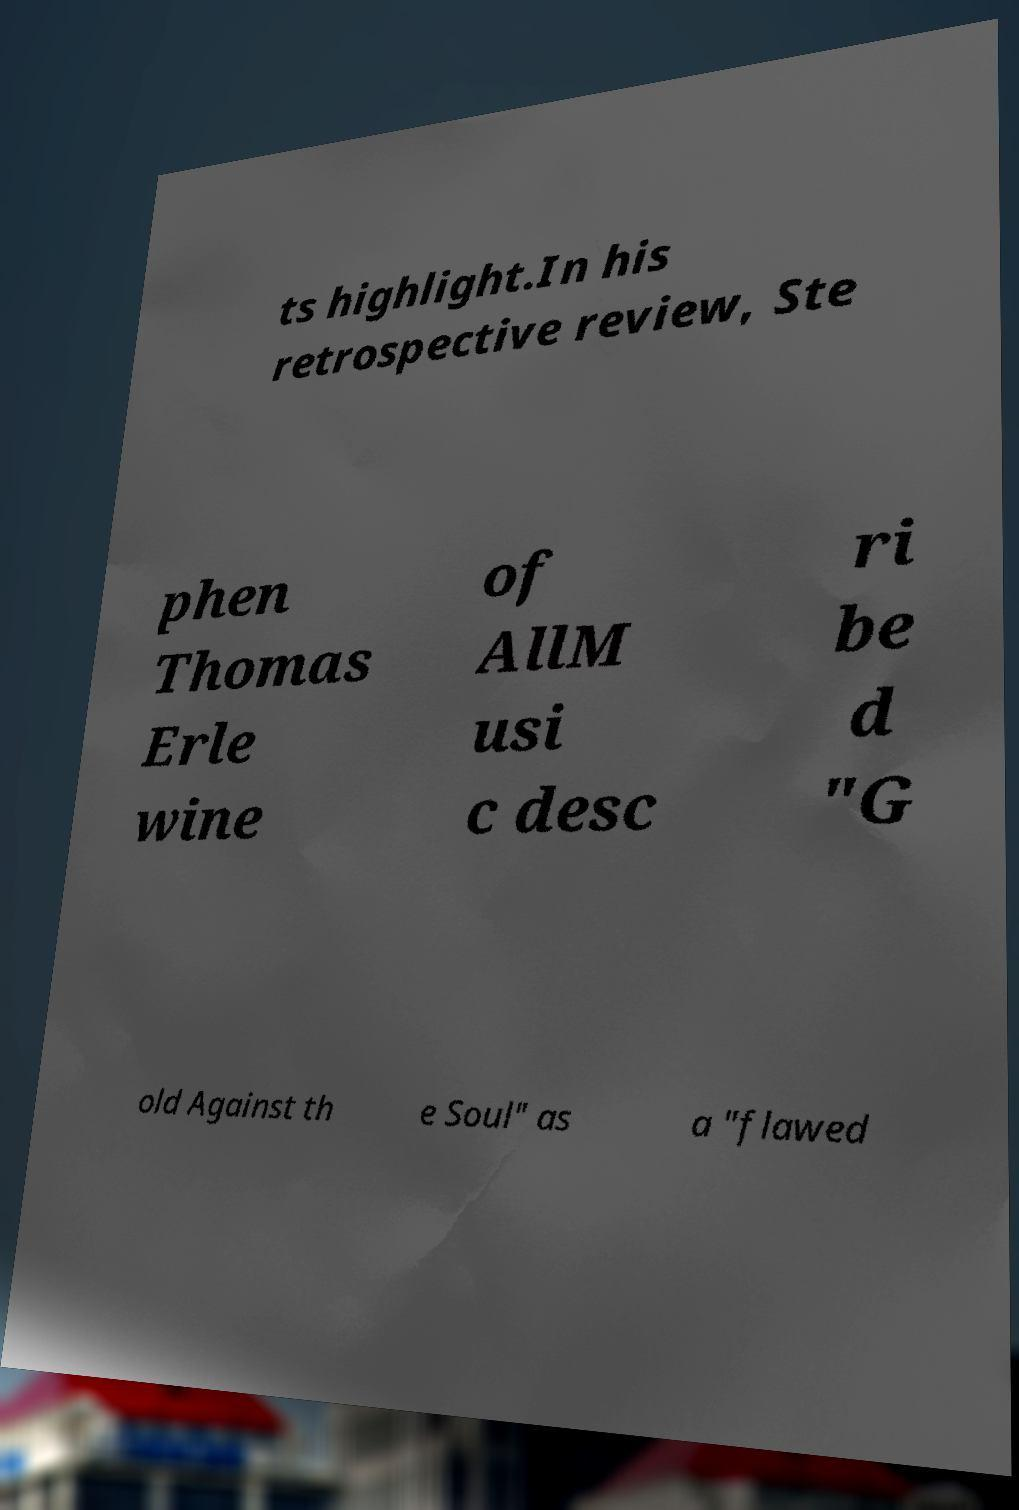I need the written content from this picture converted into text. Can you do that? ts highlight.In his retrospective review, Ste phen Thomas Erle wine of AllM usi c desc ri be d "G old Against th e Soul" as a "flawed 